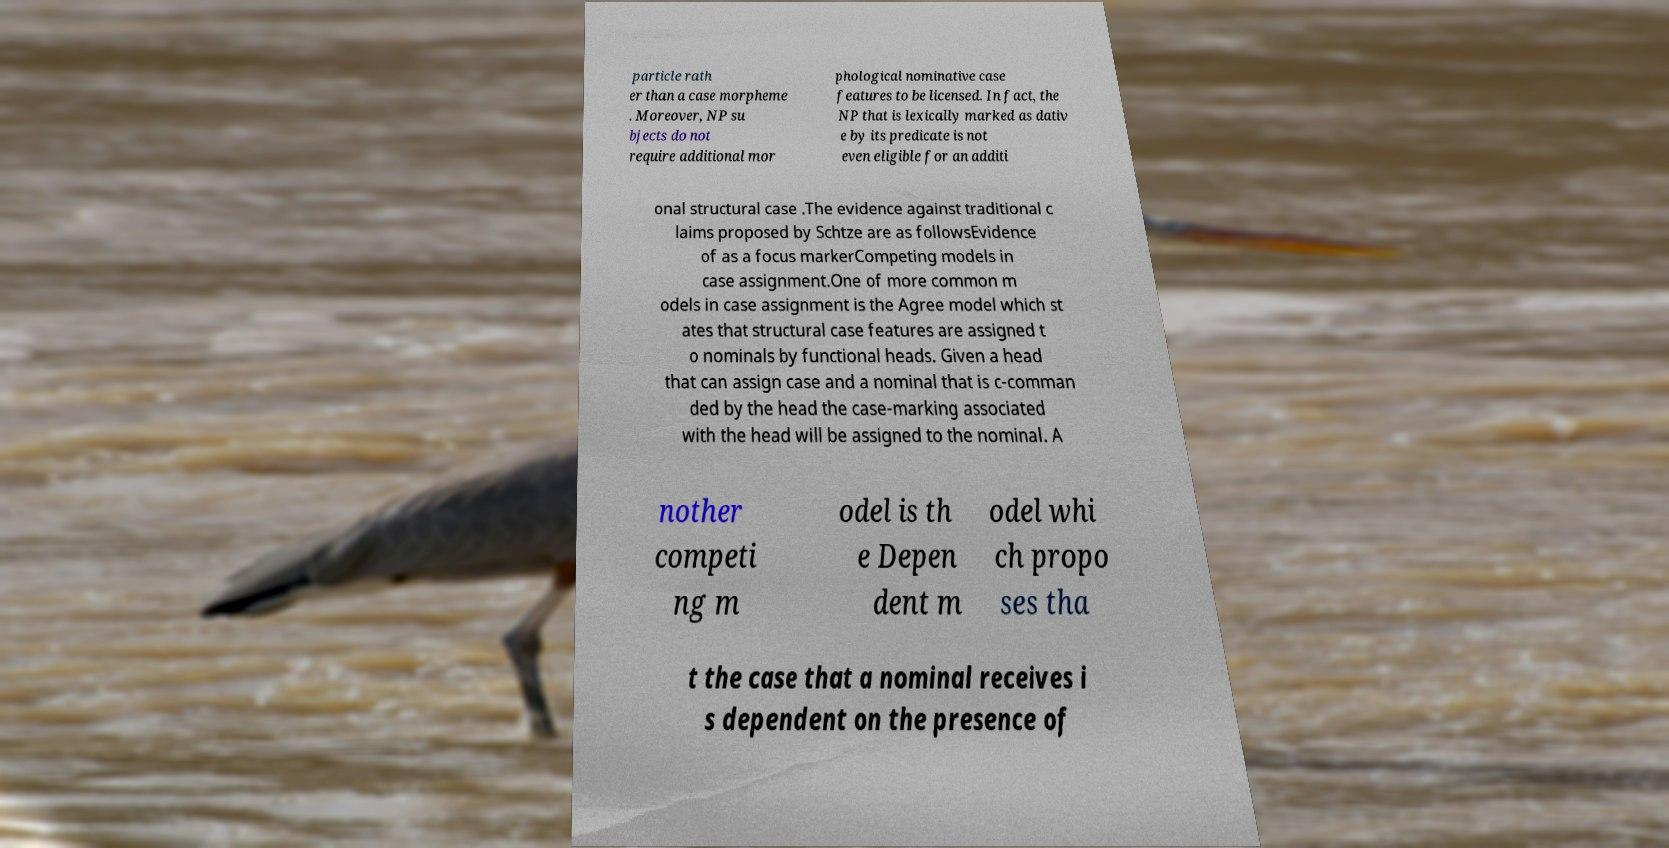I need the written content from this picture converted into text. Can you do that? particle rath er than a case morpheme . Moreover, NP su bjects do not require additional mor phological nominative case features to be licensed. In fact, the NP that is lexically marked as dativ e by its predicate is not even eligible for an additi onal structural case .The evidence against traditional c laims proposed by Schtze are as followsEvidence of as a focus markerCompeting models in case assignment.One of more common m odels in case assignment is the Agree model which st ates that structural case features are assigned t o nominals by functional heads. Given a head that can assign case and a nominal that is c-comman ded by the head the case-marking associated with the head will be assigned to the nominal. A nother competi ng m odel is th e Depen dent m odel whi ch propo ses tha t the case that a nominal receives i s dependent on the presence of 